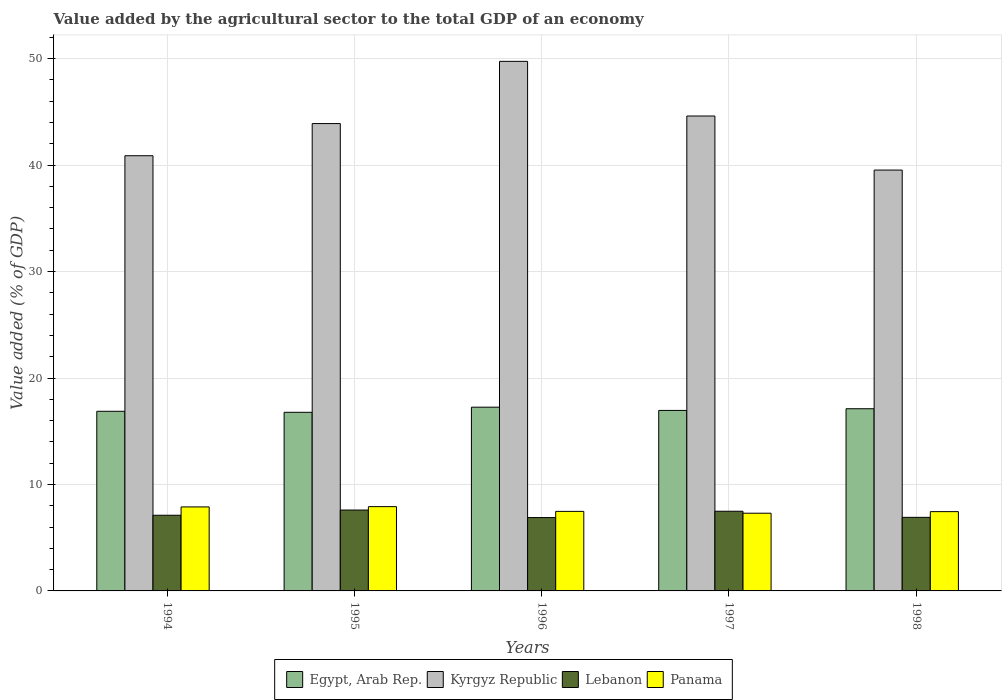How many different coloured bars are there?
Your answer should be compact. 4. How many bars are there on the 3rd tick from the right?
Ensure brevity in your answer.  4. In how many cases, is the number of bars for a given year not equal to the number of legend labels?
Offer a very short reply. 0. What is the value added by the agricultural sector to the total GDP in Kyrgyz Republic in 1998?
Your answer should be very brief. 39.53. Across all years, what is the maximum value added by the agricultural sector to the total GDP in Egypt, Arab Rep.?
Provide a succinct answer. 17.26. Across all years, what is the minimum value added by the agricultural sector to the total GDP in Egypt, Arab Rep.?
Ensure brevity in your answer.  16.78. In which year was the value added by the agricultural sector to the total GDP in Lebanon minimum?
Ensure brevity in your answer.  1996. What is the total value added by the agricultural sector to the total GDP in Kyrgyz Republic in the graph?
Make the answer very short. 218.68. What is the difference between the value added by the agricultural sector to the total GDP in Kyrgyz Republic in 1994 and that in 1998?
Offer a very short reply. 1.35. What is the difference between the value added by the agricultural sector to the total GDP in Egypt, Arab Rep. in 1998 and the value added by the agricultural sector to the total GDP in Panama in 1994?
Give a very brief answer. 9.22. What is the average value added by the agricultural sector to the total GDP in Lebanon per year?
Give a very brief answer. 7.2. In the year 1995, what is the difference between the value added by the agricultural sector to the total GDP in Lebanon and value added by the agricultural sector to the total GDP in Egypt, Arab Rep.?
Provide a succinct answer. -9.18. In how many years, is the value added by the agricultural sector to the total GDP in Egypt, Arab Rep. greater than 28 %?
Your response must be concise. 0. What is the ratio of the value added by the agricultural sector to the total GDP in Lebanon in 1995 to that in 1996?
Provide a succinct answer. 1.1. Is the value added by the agricultural sector to the total GDP in Egypt, Arab Rep. in 1994 less than that in 1998?
Keep it short and to the point. Yes. What is the difference between the highest and the second highest value added by the agricultural sector to the total GDP in Kyrgyz Republic?
Provide a short and direct response. 5.13. What is the difference between the highest and the lowest value added by the agricultural sector to the total GDP in Kyrgyz Republic?
Offer a terse response. 10.21. In how many years, is the value added by the agricultural sector to the total GDP in Kyrgyz Republic greater than the average value added by the agricultural sector to the total GDP in Kyrgyz Republic taken over all years?
Provide a short and direct response. 3. Is it the case that in every year, the sum of the value added by the agricultural sector to the total GDP in Panama and value added by the agricultural sector to the total GDP in Kyrgyz Republic is greater than the sum of value added by the agricultural sector to the total GDP in Lebanon and value added by the agricultural sector to the total GDP in Egypt, Arab Rep.?
Your answer should be very brief. Yes. What does the 1st bar from the left in 1997 represents?
Offer a very short reply. Egypt, Arab Rep. What does the 3rd bar from the right in 1996 represents?
Ensure brevity in your answer.  Kyrgyz Republic. Is it the case that in every year, the sum of the value added by the agricultural sector to the total GDP in Kyrgyz Republic and value added by the agricultural sector to the total GDP in Lebanon is greater than the value added by the agricultural sector to the total GDP in Egypt, Arab Rep.?
Your answer should be compact. Yes. What is the difference between two consecutive major ticks on the Y-axis?
Make the answer very short. 10. Are the values on the major ticks of Y-axis written in scientific E-notation?
Give a very brief answer. No. Does the graph contain any zero values?
Your answer should be compact. No. Does the graph contain grids?
Keep it short and to the point. Yes. How are the legend labels stacked?
Give a very brief answer. Horizontal. What is the title of the graph?
Your response must be concise. Value added by the agricultural sector to the total GDP of an economy. What is the label or title of the Y-axis?
Your answer should be very brief. Value added (% of GDP). What is the Value added (% of GDP) in Egypt, Arab Rep. in 1994?
Make the answer very short. 16.87. What is the Value added (% of GDP) of Kyrgyz Republic in 1994?
Provide a short and direct response. 40.88. What is the Value added (% of GDP) of Lebanon in 1994?
Ensure brevity in your answer.  7.11. What is the Value added (% of GDP) of Panama in 1994?
Give a very brief answer. 7.89. What is the Value added (% of GDP) of Egypt, Arab Rep. in 1995?
Provide a short and direct response. 16.78. What is the Value added (% of GDP) of Kyrgyz Republic in 1995?
Offer a very short reply. 43.9. What is the Value added (% of GDP) in Lebanon in 1995?
Offer a very short reply. 7.6. What is the Value added (% of GDP) of Panama in 1995?
Provide a short and direct response. 7.92. What is the Value added (% of GDP) of Egypt, Arab Rep. in 1996?
Provide a succinct answer. 17.26. What is the Value added (% of GDP) of Kyrgyz Republic in 1996?
Ensure brevity in your answer.  49.75. What is the Value added (% of GDP) of Lebanon in 1996?
Your answer should be compact. 6.89. What is the Value added (% of GDP) of Panama in 1996?
Ensure brevity in your answer.  7.47. What is the Value added (% of GDP) of Egypt, Arab Rep. in 1997?
Provide a succinct answer. 16.95. What is the Value added (% of GDP) in Kyrgyz Republic in 1997?
Your answer should be very brief. 44.61. What is the Value added (% of GDP) of Lebanon in 1997?
Your response must be concise. 7.48. What is the Value added (% of GDP) of Panama in 1997?
Provide a short and direct response. 7.3. What is the Value added (% of GDP) in Egypt, Arab Rep. in 1998?
Offer a terse response. 17.11. What is the Value added (% of GDP) in Kyrgyz Republic in 1998?
Your answer should be very brief. 39.53. What is the Value added (% of GDP) of Lebanon in 1998?
Your response must be concise. 6.91. What is the Value added (% of GDP) of Panama in 1998?
Your response must be concise. 7.45. Across all years, what is the maximum Value added (% of GDP) in Egypt, Arab Rep.?
Provide a short and direct response. 17.26. Across all years, what is the maximum Value added (% of GDP) of Kyrgyz Republic?
Your answer should be very brief. 49.75. Across all years, what is the maximum Value added (% of GDP) in Lebanon?
Make the answer very short. 7.6. Across all years, what is the maximum Value added (% of GDP) in Panama?
Offer a terse response. 7.92. Across all years, what is the minimum Value added (% of GDP) of Egypt, Arab Rep.?
Keep it short and to the point. 16.78. Across all years, what is the minimum Value added (% of GDP) of Kyrgyz Republic?
Provide a short and direct response. 39.53. Across all years, what is the minimum Value added (% of GDP) in Lebanon?
Ensure brevity in your answer.  6.89. Across all years, what is the minimum Value added (% of GDP) in Panama?
Your answer should be very brief. 7.3. What is the total Value added (% of GDP) of Egypt, Arab Rep. in the graph?
Provide a succinct answer. 84.98. What is the total Value added (% of GDP) of Kyrgyz Republic in the graph?
Keep it short and to the point. 218.68. What is the total Value added (% of GDP) of Lebanon in the graph?
Provide a succinct answer. 35.99. What is the total Value added (% of GDP) in Panama in the graph?
Offer a terse response. 38.03. What is the difference between the Value added (% of GDP) in Egypt, Arab Rep. in 1994 and that in 1995?
Provide a short and direct response. 0.1. What is the difference between the Value added (% of GDP) of Kyrgyz Republic in 1994 and that in 1995?
Your answer should be compact. -3.02. What is the difference between the Value added (% of GDP) in Lebanon in 1994 and that in 1995?
Give a very brief answer. -0.49. What is the difference between the Value added (% of GDP) of Panama in 1994 and that in 1995?
Give a very brief answer. -0.03. What is the difference between the Value added (% of GDP) in Egypt, Arab Rep. in 1994 and that in 1996?
Your answer should be very brief. -0.39. What is the difference between the Value added (% of GDP) of Kyrgyz Republic in 1994 and that in 1996?
Ensure brevity in your answer.  -8.87. What is the difference between the Value added (% of GDP) in Lebanon in 1994 and that in 1996?
Offer a terse response. 0.22. What is the difference between the Value added (% of GDP) in Panama in 1994 and that in 1996?
Offer a terse response. 0.42. What is the difference between the Value added (% of GDP) of Egypt, Arab Rep. in 1994 and that in 1997?
Provide a short and direct response. -0.08. What is the difference between the Value added (% of GDP) in Kyrgyz Republic in 1994 and that in 1997?
Provide a short and direct response. -3.73. What is the difference between the Value added (% of GDP) of Lebanon in 1994 and that in 1997?
Keep it short and to the point. -0.38. What is the difference between the Value added (% of GDP) of Panama in 1994 and that in 1997?
Give a very brief answer. 0.59. What is the difference between the Value added (% of GDP) in Egypt, Arab Rep. in 1994 and that in 1998?
Give a very brief answer. -0.24. What is the difference between the Value added (% of GDP) in Kyrgyz Republic in 1994 and that in 1998?
Ensure brevity in your answer.  1.35. What is the difference between the Value added (% of GDP) of Lebanon in 1994 and that in 1998?
Offer a terse response. 0.2. What is the difference between the Value added (% of GDP) in Panama in 1994 and that in 1998?
Keep it short and to the point. 0.44. What is the difference between the Value added (% of GDP) of Egypt, Arab Rep. in 1995 and that in 1996?
Offer a terse response. -0.48. What is the difference between the Value added (% of GDP) of Kyrgyz Republic in 1995 and that in 1996?
Make the answer very short. -5.84. What is the difference between the Value added (% of GDP) in Lebanon in 1995 and that in 1996?
Offer a terse response. 0.71. What is the difference between the Value added (% of GDP) in Panama in 1995 and that in 1996?
Provide a short and direct response. 0.45. What is the difference between the Value added (% of GDP) in Egypt, Arab Rep. in 1995 and that in 1997?
Provide a succinct answer. -0.18. What is the difference between the Value added (% of GDP) in Kyrgyz Republic in 1995 and that in 1997?
Give a very brief answer. -0.71. What is the difference between the Value added (% of GDP) in Lebanon in 1995 and that in 1997?
Your answer should be compact. 0.11. What is the difference between the Value added (% of GDP) in Panama in 1995 and that in 1997?
Your answer should be compact. 0.62. What is the difference between the Value added (% of GDP) in Egypt, Arab Rep. in 1995 and that in 1998?
Provide a succinct answer. -0.33. What is the difference between the Value added (% of GDP) of Kyrgyz Republic in 1995 and that in 1998?
Give a very brief answer. 4.37. What is the difference between the Value added (% of GDP) in Lebanon in 1995 and that in 1998?
Offer a terse response. 0.69. What is the difference between the Value added (% of GDP) of Panama in 1995 and that in 1998?
Ensure brevity in your answer.  0.47. What is the difference between the Value added (% of GDP) in Egypt, Arab Rep. in 1996 and that in 1997?
Keep it short and to the point. 0.31. What is the difference between the Value added (% of GDP) in Kyrgyz Republic in 1996 and that in 1997?
Your response must be concise. 5.13. What is the difference between the Value added (% of GDP) of Lebanon in 1996 and that in 1997?
Make the answer very short. -0.59. What is the difference between the Value added (% of GDP) in Panama in 1996 and that in 1997?
Provide a succinct answer. 0.17. What is the difference between the Value added (% of GDP) in Egypt, Arab Rep. in 1996 and that in 1998?
Give a very brief answer. 0.15. What is the difference between the Value added (% of GDP) in Kyrgyz Republic in 1996 and that in 1998?
Give a very brief answer. 10.21. What is the difference between the Value added (% of GDP) in Lebanon in 1996 and that in 1998?
Ensure brevity in your answer.  -0.02. What is the difference between the Value added (% of GDP) of Panama in 1996 and that in 1998?
Make the answer very short. 0.02. What is the difference between the Value added (% of GDP) of Egypt, Arab Rep. in 1997 and that in 1998?
Ensure brevity in your answer.  -0.16. What is the difference between the Value added (% of GDP) of Kyrgyz Republic in 1997 and that in 1998?
Make the answer very short. 5.08. What is the difference between the Value added (% of GDP) of Lebanon in 1997 and that in 1998?
Your answer should be very brief. 0.57. What is the difference between the Value added (% of GDP) of Panama in 1997 and that in 1998?
Keep it short and to the point. -0.15. What is the difference between the Value added (% of GDP) of Egypt, Arab Rep. in 1994 and the Value added (% of GDP) of Kyrgyz Republic in 1995?
Offer a very short reply. -27.03. What is the difference between the Value added (% of GDP) of Egypt, Arab Rep. in 1994 and the Value added (% of GDP) of Lebanon in 1995?
Make the answer very short. 9.28. What is the difference between the Value added (% of GDP) of Egypt, Arab Rep. in 1994 and the Value added (% of GDP) of Panama in 1995?
Provide a succinct answer. 8.96. What is the difference between the Value added (% of GDP) of Kyrgyz Republic in 1994 and the Value added (% of GDP) of Lebanon in 1995?
Give a very brief answer. 33.28. What is the difference between the Value added (% of GDP) of Kyrgyz Republic in 1994 and the Value added (% of GDP) of Panama in 1995?
Make the answer very short. 32.96. What is the difference between the Value added (% of GDP) of Lebanon in 1994 and the Value added (% of GDP) of Panama in 1995?
Provide a succinct answer. -0.81. What is the difference between the Value added (% of GDP) in Egypt, Arab Rep. in 1994 and the Value added (% of GDP) in Kyrgyz Republic in 1996?
Offer a terse response. -32.87. What is the difference between the Value added (% of GDP) of Egypt, Arab Rep. in 1994 and the Value added (% of GDP) of Lebanon in 1996?
Give a very brief answer. 9.98. What is the difference between the Value added (% of GDP) of Egypt, Arab Rep. in 1994 and the Value added (% of GDP) of Panama in 1996?
Provide a succinct answer. 9.4. What is the difference between the Value added (% of GDP) of Kyrgyz Republic in 1994 and the Value added (% of GDP) of Lebanon in 1996?
Provide a short and direct response. 33.99. What is the difference between the Value added (% of GDP) of Kyrgyz Republic in 1994 and the Value added (% of GDP) of Panama in 1996?
Provide a succinct answer. 33.41. What is the difference between the Value added (% of GDP) of Lebanon in 1994 and the Value added (% of GDP) of Panama in 1996?
Your response must be concise. -0.36. What is the difference between the Value added (% of GDP) in Egypt, Arab Rep. in 1994 and the Value added (% of GDP) in Kyrgyz Republic in 1997?
Ensure brevity in your answer.  -27.74. What is the difference between the Value added (% of GDP) in Egypt, Arab Rep. in 1994 and the Value added (% of GDP) in Lebanon in 1997?
Your response must be concise. 9.39. What is the difference between the Value added (% of GDP) in Egypt, Arab Rep. in 1994 and the Value added (% of GDP) in Panama in 1997?
Ensure brevity in your answer.  9.57. What is the difference between the Value added (% of GDP) of Kyrgyz Republic in 1994 and the Value added (% of GDP) of Lebanon in 1997?
Make the answer very short. 33.4. What is the difference between the Value added (% of GDP) in Kyrgyz Republic in 1994 and the Value added (% of GDP) in Panama in 1997?
Provide a succinct answer. 33.58. What is the difference between the Value added (% of GDP) of Lebanon in 1994 and the Value added (% of GDP) of Panama in 1997?
Make the answer very short. -0.19. What is the difference between the Value added (% of GDP) of Egypt, Arab Rep. in 1994 and the Value added (% of GDP) of Kyrgyz Republic in 1998?
Offer a terse response. -22.66. What is the difference between the Value added (% of GDP) of Egypt, Arab Rep. in 1994 and the Value added (% of GDP) of Lebanon in 1998?
Your answer should be very brief. 9.96. What is the difference between the Value added (% of GDP) in Egypt, Arab Rep. in 1994 and the Value added (% of GDP) in Panama in 1998?
Offer a terse response. 9.43. What is the difference between the Value added (% of GDP) of Kyrgyz Republic in 1994 and the Value added (% of GDP) of Lebanon in 1998?
Provide a short and direct response. 33.97. What is the difference between the Value added (% of GDP) of Kyrgyz Republic in 1994 and the Value added (% of GDP) of Panama in 1998?
Provide a short and direct response. 33.43. What is the difference between the Value added (% of GDP) in Lebanon in 1994 and the Value added (% of GDP) in Panama in 1998?
Offer a terse response. -0.34. What is the difference between the Value added (% of GDP) in Egypt, Arab Rep. in 1995 and the Value added (% of GDP) in Kyrgyz Republic in 1996?
Provide a short and direct response. -32.97. What is the difference between the Value added (% of GDP) in Egypt, Arab Rep. in 1995 and the Value added (% of GDP) in Lebanon in 1996?
Offer a terse response. 9.89. What is the difference between the Value added (% of GDP) in Egypt, Arab Rep. in 1995 and the Value added (% of GDP) in Panama in 1996?
Offer a very short reply. 9.31. What is the difference between the Value added (% of GDP) of Kyrgyz Republic in 1995 and the Value added (% of GDP) of Lebanon in 1996?
Your answer should be very brief. 37.01. What is the difference between the Value added (% of GDP) in Kyrgyz Republic in 1995 and the Value added (% of GDP) in Panama in 1996?
Ensure brevity in your answer.  36.43. What is the difference between the Value added (% of GDP) in Lebanon in 1995 and the Value added (% of GDP) in Panama in 1996?
Your answer should be compact. 0.13. What is the difference between the Value added (% of GDP) in Egypt, Arab Rep. in 1995 and the Value added (% of GDP) in Kyrgyz Republic in 1997?
Provide a succinct answer. -27.83. What is the difference between the Value added (% of GDP) in Egypt, Arab Rep. in 1995 and the Value added (% of GDP) in Lebanon in 1997?
Your answer should be compact. 9.29. What is the difference between the Value added (% of GDP) of Egypt, Arab Rep. in 1995 and the Value added (% of GDP) of Panama in 1997?
Provide a succinct answer. 9.48. What is the difference between the Value added (% of GDP) of Kyrgyz Republic in 1995 and the Value added (% of GDP) of Lebanon in 1997?
Keep it short and to the point. 36.42. What is the difference between the Value added (% of GDP) of Kyrgyz Republic in 1995 and the Value added (% of GDP) of Panama in 1997?
Ensure brevity in your answer.  36.6. What is the difference between the Value added (% of GDP) in Lebanon in 1995 and the Value added (% of GDP) in Panama in 1997?
Provide a short and direct response. 0.3. What is the difference between the Value added (% of GDP) in Egypt, Arab Rep. in 1995 and the Value added (% of GDP) in Kyrgyz Republic in 1998?
Offer a very short reply. -22.75. What is the difference between the Value added (% of GDP) of Egypt, Arab Rep. in 1995 and the Value added (% of GDP) of Lebanon in 1998?
Make the answer very short. 9.87. What is the difference between the Value added (% of GDP) of Egypt, Arab Rep. in 1995 and the Value added (% of GDP) of Panama in 1998?
Make the answer very short. 9.33. What is the difference between the Value added (% of GDP) of Kyrgyz Republic in 1995 and the Value added (% of GDP) of Lebanon in 1998?
Make the answer very short. 36.99. What is the difference between the Value added (% of GDP) of Kyrgyz Republic in 1995 and the Value added (% of GDP) of Panama in 1998?
Keep it short and to the point. 36.45. What is the difference between the Value added (% of GDP) of Lebanon in 1995 and the Value added (% of GDP) of Panama in 1998?
Offer a very short reply. 0.15. What is the difference between the Value added (% of GDP) in Egypt, Arab Rep. in 1996 and the Value added (% of GDP) in Kyrgyz Republic in 1997?
Your answer should be very brief. -27.35. What is the difference between the Value added (% of GDP) of Egypt, Arab Rep. in 1996 and the Value added (% of GDP) of Lebanon in 1997?
Your answer should be compact. 9.78. What is the difference between the Value added (% of GDP) in Egypt, Arab Rep. in 1996 and the Value added (% of GDP) in Panama in 1997?
Your answer should be compact. 9.96. What is the difference between the Value added (% of GDP) of Kyrgyz Republic in 1996 and the Value added (% of GDP) of Lebanon in 1997?
Provide a succinct answer. 42.26. What is the difference between the Value added (% of GDP) of Kyrgyz Republic in 1996 and the Value added (% of GDP) of Panama in 1997?
Your response must be concise. 42.45. What is the difference between the Value added (% of GDP) of Lebanon in 1996 and the Value added (% of GDP) of Panama in 1997?
Your answer should be compact. -0.41. What is the difference between the Value added (% of GDP) in Egypt, Arab Rep. in 1996 and the Value added (% of GDP) in Kyrgyz Republic in 1998?
Keep it short and to the point. -22.27. What is the difference between the Value added (% of GDP) of Egypt, Arab Rep. in 1996 and the Value added (% of GDP) of Lebanon in 1998?
Your answer should be very brief. 10.35. What is the difference between the Value added (% of GDP) of Egypt, Arab Rep. in 1996 and the Value added (% of GDP) of Panama in 1998?
Provide a short and direct response. 9.81. What is the difference between the Value added (% of GDP) of Kyrgyz Republic in 1996 and the Value added (% of GDP) of Lebanon in 1998?
Provide a succinct answer. 42.84. What is the difference between the Value added (% of GDP) of Kyrgyz Republic in 1996 and the Value added (% of GDP) of Panama in 1998?
Provide a succinct answer. 42.3. What is the difference between the Value added (% of GDP) in Lebanon in 1996 and the Value added (% of GDP) in Panama in 1998?
Offer a very short reply. -0.56. What is the difference between the Value added (% of GDP) in Egypt, Arab Rep. in 1997 and the Value added (% of GDP) in Kyrgyz Republic in 1998?
Make the answer very short. -22.58. What is the difference between the Value added (% of GDP) in Egypt, Arab Rep. in 1997 and the Value added (% of GDP) in Lebanon in 1998?
Ensure brevity in your answer.  10.04. What is the difference between the Value added (% of GDP) in Egypt, Arab Rep. in 1997 and the Value added (% of GDP) in Panama in 1998?
Ensure brevity in your answer.  9.51. What is the difference between the Value added (% of GDP) in Kyrgyz Republic in 1997 and the Value added (% of GDP) in Lebanon in 1998?
Offer a terse response. 37.7. What is the difference between the Value added (% of GDP) of Kyrgyz Republic in 1997 and the Value added (% of GDP) of Panama in 1998?
Offer a terse response. 37.16. What is the difference between the Value added (% of GDP) of Lebanon in 1997 and the Value added (% of GDP) of Panama in 1998?
Your answer should be very brief. 0.04. What is the average Value added (% of GDP) of Egypt, Arab Rep. per year?
Ensure brevity in your answer.  17. What is the average Value added (% of GDP) in Kyrgyz Republic per year?
Your response must be concise. 43.74. What is the average Value added (% of GDP) of Lebanon per year?
Make the answer very short. 7.2. What is the average Value added (% of GDP) of Panama per year?
Keep it short and to the point. 7.61. In the year 1994, what is the difference between the Value added (% of GDP) in Egypt, Arab Rep. and Value added (% of GDP) in Kyrgyz Republic?
Give a very brief answer. -24.01. In the year 1994, what is the difference between the Value added (% of GDP) of Egypt, Arab Rep. and Value added (% of GDP) of Lebanon?
Your answer should be compact. 9.77. In the year 1994, what is the difference between the Value added (% of GDP) of Egypt, Arab Rep. and Value added (% of GDP) of Panama?
Keep it short and to the point. 8.98. In the year 1994, what is the difference between the Value added (% of GDP) of Kyrgyz Republic and Value added (% of GDP) of Lebanon?
Ensure brevity in your answer.  33.77. In the year 1994, what is the difference between the Value added (% of GDP) in Kyrgyz Republic and Value added (% of GDP) in Panama?
Your answer should be compact. 32.99. In the year 1994, what is the difference between the Value added (% of GDP) in Lebanon and Value added (% of GDP) in Panama?
Offer a very short reply. -0.78. In the year 1995, what is the difference between the Value added (% of GDP) in Egypt, Arab Rep. and Value added (% of GDP) in Kyrgyz Republic?
Provide a short and direct response. -27.12. In the year 1995, what is the difference between the Value added (% of GDP) in Egypt, Arab Rep. and Value added (% of GDP) in Lebanon?
Ensure brevity in your answer.  9.18. In the year 1995, what is the difference between the Value added (% of GDP) in Egypt, Arab Rep. and Value added (% of GDP) in Panama?
Offer a very short reply. 8.86. In the year 1995, what is the difference between the Value added (% of GDP) in Kyrgyz Republic and Value added (% of GDP) in Lebanon?
Your answer should be very brief. 36.3. In the year 1995, what is the difference between the Value added (% of GDP) in Kyrgyz Republic and Value added (% of GDP) in Panama?
Your response must be concise. 35.98. In the year 1995, what is the difference between the Value added (% of GDP) of Lebanon and Value added (% of GDP) of Panama?
Give a very brief answer. -0.32. In the year 1996, what is the difference between the Value added (% of GDP) of Egypt, Arab Rep. and Value added (% of GDP) of Kyrgyz Republic?
Provide a short and direct response. -32.49. In the year 1996, what is the difference between the Value added (% of GDP) of Egypt, Arab Rep. and Value added (% of GDP) of Lebanon?
Your answer should be very brief. 10.37. In the year 1996, what is the difference between the Value added (% of GDP) of Egypt, Arab Rep. and Value added (% of GDP) of Panama?
Provide a short and direct response. 9.79. In the year 1996, what is the difference between the Value added (% of GDP) of Kyrgyz Republic and Value added (% of GDP) of Lebanon?
Give a very brief answer. 42.86. In the year 1996, what is the difference between the Value added (% of GDP) of Kyrgyz Republic and Value added (% of GDP) of Panama?
Provide a succinct answer. 42.27. In the year 1996, what is the difference between the Value added (% of GDP) in Lebanon and Value added (% of GDP) in Panama?
Make the answer very short. -0.58. In the year 1997, what is the difference between the Value added (% of GDP) in Egypt, Arab Rep. and Value added (% of GDP) in Kyrgyz Republic?
Your answer should be compact. -27.66. In the year 1997, what is the difference between the Value added (% of GDP) in Egypt, Arab Rep. and Value added (% of GDP) in Lebanon?
Your answer should be very brief. 9.47. In the year 1997, what is the difference between the Value added (% of GDP) of Egypt, Arab Rep. and Value added (% of GDP) of Panama?
Your answer should be compact. 9.65. In the year 1997, what is the difference between the Value added (% of GDP) in Kyrgyz Republic and Value added (% of GDP) in Lebanon?
Provide a succinct answer. 37.13. In the year 1997, what is the difference between the Value added (% of GDP) of Kyrgyz Republic and Value added (% of GDP) of Panama?
Your answer should be very brief. 37.31. In the year 1997, what is the difference between the Value added (% of GDP) of Lebanon and Value added (% of GDP) of Panama?
Your response must be concise. 0.18. In the year 1998, what is the difference between the Value added (% of GDP) in Egypt, Arab Rep. and Value added (% of GDP) in Kyrgyz Republic?
Provide a succinct answer. -22.42. In the year 1998, what is the difference between the Value added (% of GDP) in Egypt, Arab Rep. and Value added (% of GDP) in Lebanon?
Make the answer very short. 10.2. In the year 1998, what is the difference between the Value added (% of GDP) in Egypt, Arab Rep. and Value added (% of GDP) in Panama?
Your response must be concise. 9.67. In the year 1998, what is the difference between the Value added (% of GDP) in Kyrgyz Republic and Value added (% of GDP) in Lebanon?
Keep it short and to the point. 32.62. In the year 1998, what is the difference between the Value added (% of GDP) in Kyrgyz Republic and Value added (% of GDP) in Panama?
Offer a terse response. 32.08. In the year 1998, what is the difference between the Value added (% of GDP) of Lebanon and Value added (% of GDP) of Panama?
Your answer should be very brief. -0.54. What is the ratio of the Value added (% of GDP) of Egypt, Arab Rep. in 1994 to that in 1995?
Ensure brevity in your answer.  1.01. What is the ratio of the Value added (% of GDP) of Kyrgyz Republic in 1994 to that in 1995?
Offer a very short reply. 0.93. What is the ratio of the Value added (% of GDP) of Lebanon in 1994 to that in 1995?
Make the answer very short. 0.94. What is the ratio of the Value added (% of GDP) in Egypt, Arab Rep. in 1994 to that in 1996?
Give a very brief answer. 0.98. What is the ratio of the Value added (% of GDP) of Kyrgyz Republic in 1994 to that in 1996?
Offer a very short reply. 0.82. What is the ratio of the Value added (% of GDP) in Lebanon in 1994 to that in 1996?
Your answer should be very brief. 1.03. What is the ratio of the Value added (% of GDP) of Panama in 1994 to that in 1996?
Your answer should be compact. 1.06. What is the ratio of the Value added (% of GDP) of Kyrgyz Republic in 1994 to that in 1997?
Make the answer very short. 0.92. What is the ratio of the Value added (% of GDP) of Lebanon in 1994 to that in 1997?
Make the answer very short. 0.95. What is the ratio of the Value added (% of GDP) in Panama in 1994 to that in 1997?
Provide a succinct answer. 1.08. What is the ratio of the Value added (% of GDP) in Egypt, Arab Rep. in 1994 to that in 1998?
Ensure brevity in your answer.  0.99. What is the ratio of the Value added (% of GDP) in Kyrgyz Republic in 1994 to that in 1998?
Provide a succinct answer. 1.03. What is the ratio of the Value added (% of GDP) of Lebanon in 1994 to that in 1998?
Provide a short and direct response. 1.03. What is the ratio of the Value added (% of GDP) of Panama in 1994 to that in 1998?
Offer a terse response. 1.06. What is the ratio of the Value added (% of GDP) of Egypt, Arab Rep. in 1995 to that in 1996?
Offer a terse response. 0.97. What is the ratio of the Value added (% of GDP) in Kyrgyz Republic in 1995 to that in 1996?
Offer a very short reply. 0.88. What is the ratio of the Value added (% of GDP) in Lebanon in 1995 to that in 1996?
Offer a very short reply. 1.1. What is the ratio of the Value added (% of GDP) in Panama in 1995 to that in 1996?
Ensure brevity in your answer.  1.06. What is the ratio of the Value added (% of GDP) of Egypt, Arab Rep. in 1995 to that in 1997?
Keep it short and to the point. 0.99. What is the ratio of the Value added (% of GDP) of Kyrgyz Republic in 1995 to that in 1997?
Offer a terse response. 0.98. What is the ratio of the Value added (% of GDP) of Lebanon in 1995 to that in 1997?
Your answer should be compact. 1.02. What is the ratio of the Value added (% of GDP) of Panama in 1995 to that in 1997?
Provide a short and direct response. 1.08. What is the ratio of the Value added (% of GDP) in Egypt, Arab Rep. in 1995 to that in 1998?
Keep it short and to the point. 0.98. What is the ratio of the Value added (% of GDP) in Kyrgyz Republic in 1995 to that in 1998?
Keep it short and to the point. 1.11. What is the ratio of the Value added (% of GDP) in Lebanon in 1995 to that in 1998?
Your answer should be very brief. 1.1. What is the ratio of the Value added (% of GDP) in Panama in 1995 to that in 1998?
Your answer should be compact. 1.06. What is the ratio of the Value added (% of GDP) in Egypt, Arab Rep. in 1996 to that in 1997?
Provide a short and direct response. 1.02. What is the ratio of the Value added (% of GDP) in Kyrgyz Republic in 1996 to that in 1997?
Keep it short and to the point. 1.12. What is the ratio of the Value added (% of GDP) in Lebanon in 1996 to that in 1997?
Offer a terse response. 0.92. What is the ratio of the Value added (% of GDP) in Panama in 1996 to that in 1997?
Your answer should be very brief. 1.02. What is the ratio of the Value added (% of GDP) in Egypt, Arab Rep. in 1996 to that in 1998?
Ensure brevity in your answer.  1.01. What is the ratio of the Value added (% of GDP) in Kyrgyz Republic in 1996 to that in 1998?
Offer a terse response. 1.26. What is the ratio of the Value added (% of GDP) in Lebanon in 1996 to that in 1998?
Provide a succinct answer. 1. What is the ratio of the Value added (% of GDP) in Egypt, Arab Rep. in 1997 to that in 1998?
Your response must be concise. 0.99. What is the ratio of the Value added (% of GDP) in Kyrgyz Republic in 1997 to that in 1998?
Your answer should be very brief. 1.13. What is the ratio of the Value added (% of GDP) in Lebanon in 1997 to that in 1998?
Provide a succinct answer. 1.08. What is the ratio of the Value added (% of GDP) in Panama in 1997 to that in 1998?
Offer a terse response. 0.98. What is the difference between the highest and the second highest Value added (% of GDP) in Egypt, Arab Rep.?
Your response must be concise. 0.15. What is the difference between the highest and the second highest Value added (% of GDP) in Kyrgyz Republic?
Keep it short and to the point. 5.13. What is the difference between the highest and the second highest Value added (% of GDP) in Lebanon?
Make the answer very short. 0.11. What is the difference between the highest and the second highest Value added (% of GDP) of Panama?
Ensure brevity in your answer.  0.03. What is the difference between the highest and the lowest Value added (% of GDP) in Egypt, Arab Rep.?
Your answer should be compact. 0.48. What is the difference between the highest and the lowest Value added (% of GDP) in Kyrgyz Republic?
Your response must be concise. 10.21. What is the difference between the highest and the lowest Value added (% of GDP) in Lebanon?
Offer a terse response. 0.71. What is the difference between the highest and the lowest Value added (% of GDP) in Panama?
Your answer should be compact. 0.62. 